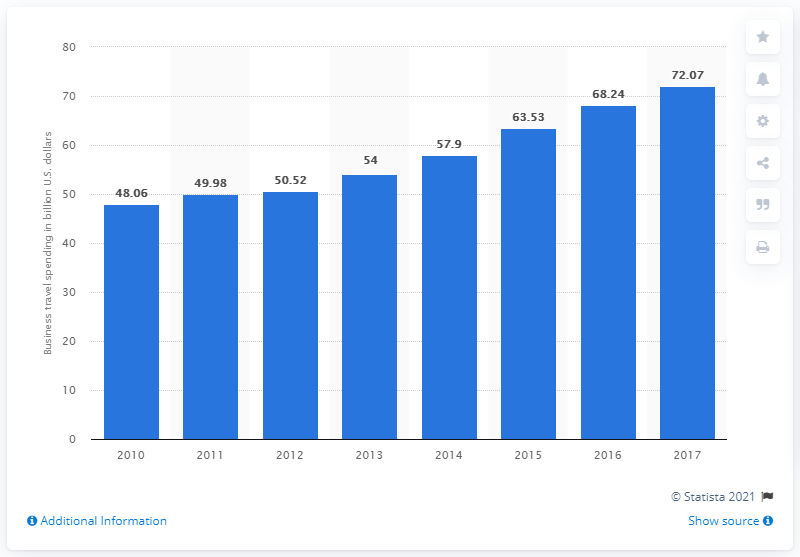Highlight a few significant elements in this photo. In 2017, Germany's business travel spending was 72.07 million. 